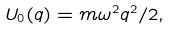Convert formula to latex. <formula><loc_0><loc_0><loc_500><loc_500>U _ { 0 } ( q ) = m \omega ^ { 2 } q ^ { 2 } / 2 ,</formula> 